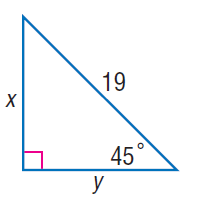Answer the mathemtical geometry problem and directly provide the correct option letter.
Question: Find x.
Choices: A: \frac { 17 \sqrt { 2 } } { 2 } B: \frac { 19 \sqrt { 2 } } { 2 } C: \frac { 21 \sqrt { 2 } } { 2 } D: \frac { 23 \sqrt { 2 } } { 2 } B 